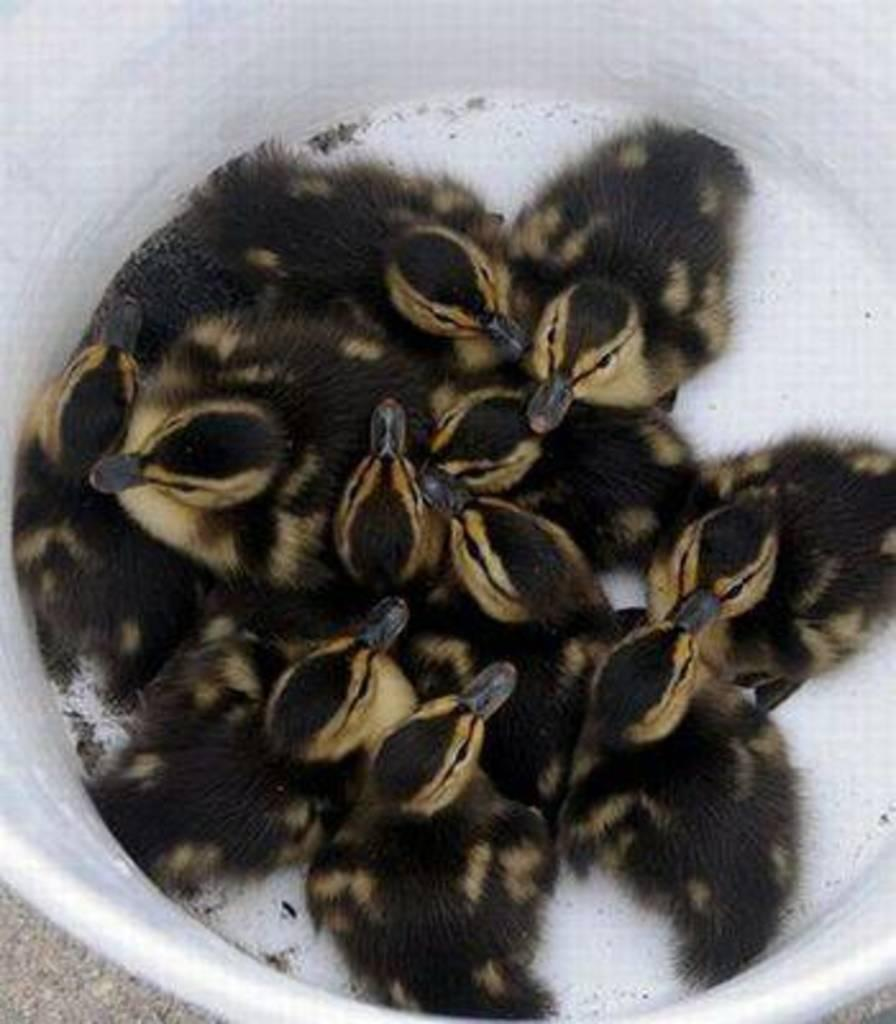What type of animals are in the image? There are ducklings in the image. Where are the ducklings located? The ducklings are in a tub. What is the color of the tub? The tub is white in color. What type of discovery can be seen in the image? There is no discovery present in the image; it features ducklings in a tub. What type of flame can be seen in the image? There is no flame present in the image. 